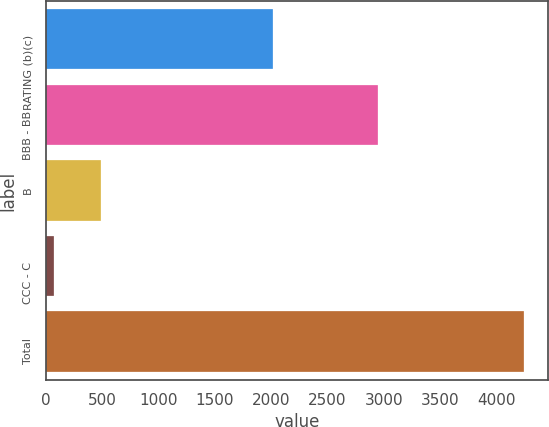Convert chart. <chart><loc_0><loc_0><loc_500><loc_500><bar_chart><fcel>RATING (b)(c)<fcel>BBB - BB<fcel>B<fcel>CCC - C<fcel>Total<nl><fcel>2014<fcel>2952<fcel>485.5<fcel>67<fcel>4252<nl></chart> 